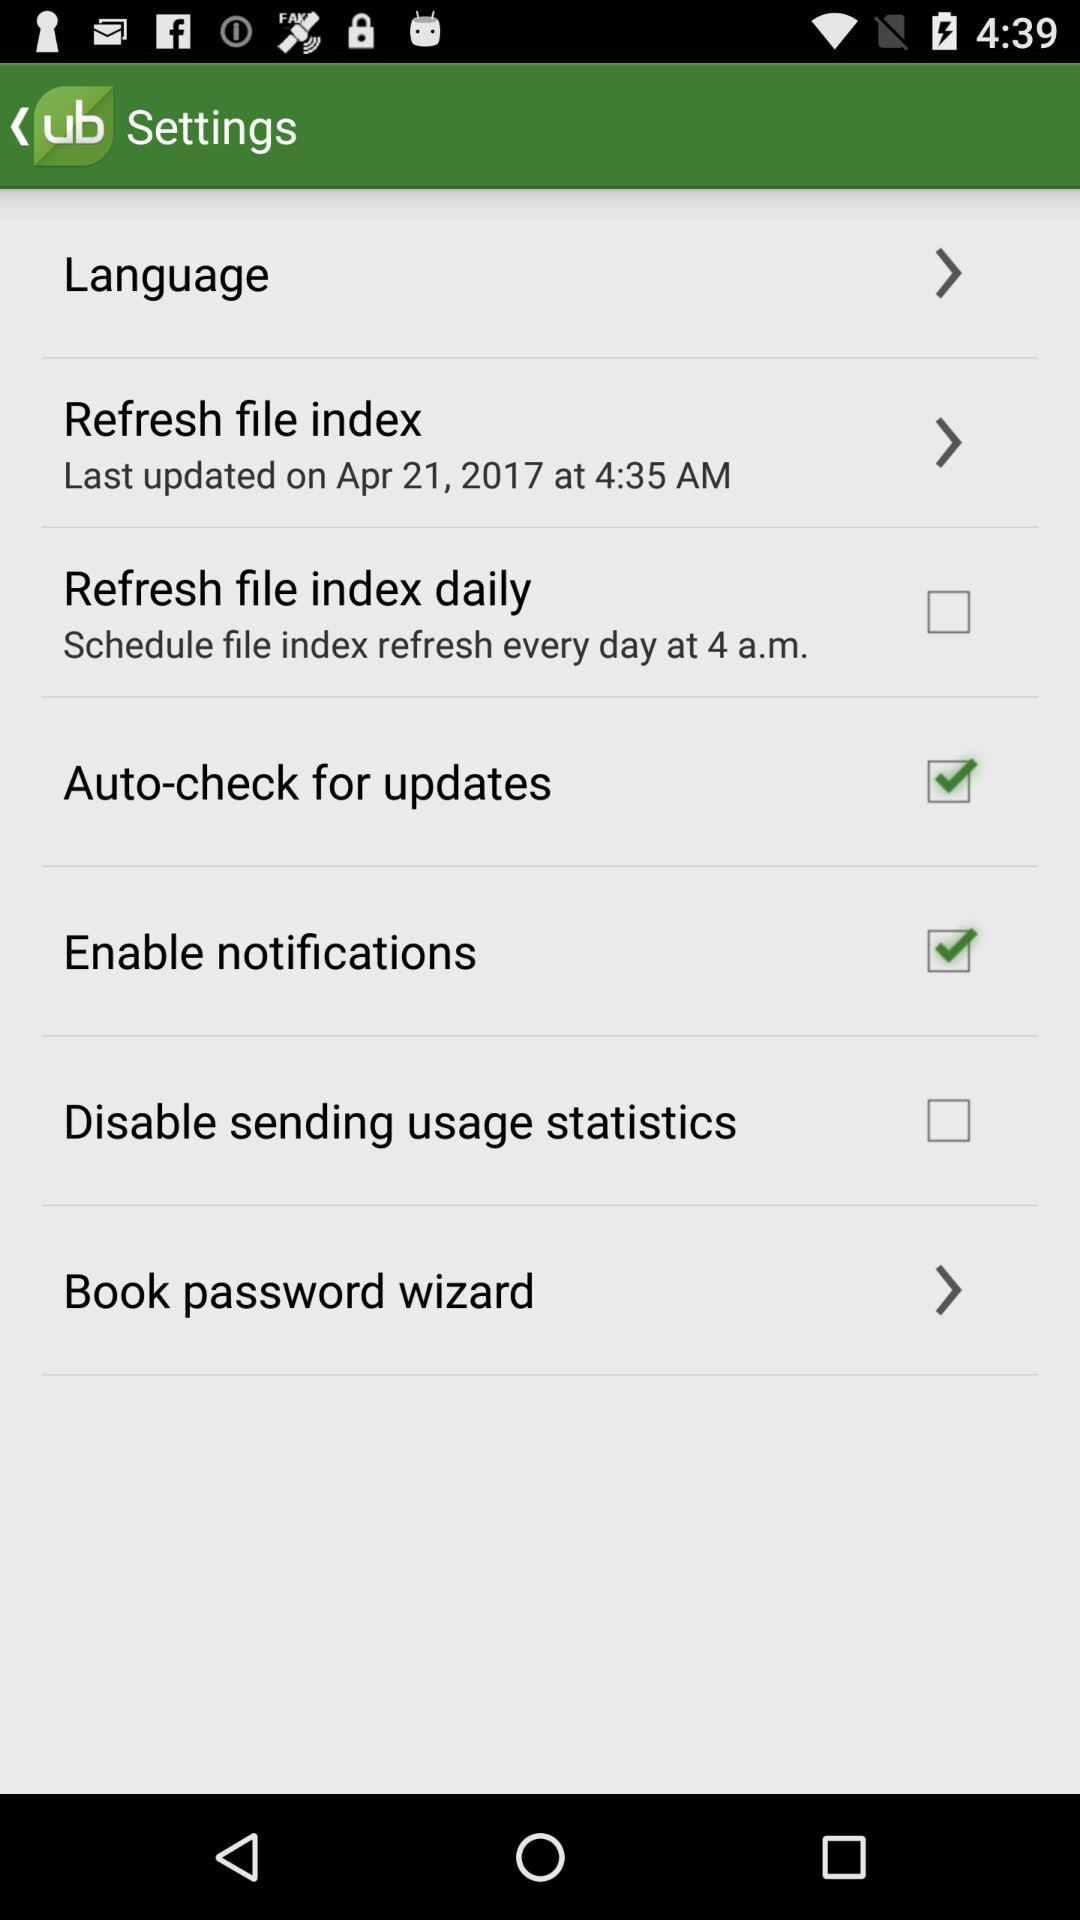What is the refresh time for "Refresh file index daily"? The refresh time is every day at 4 a.m. 